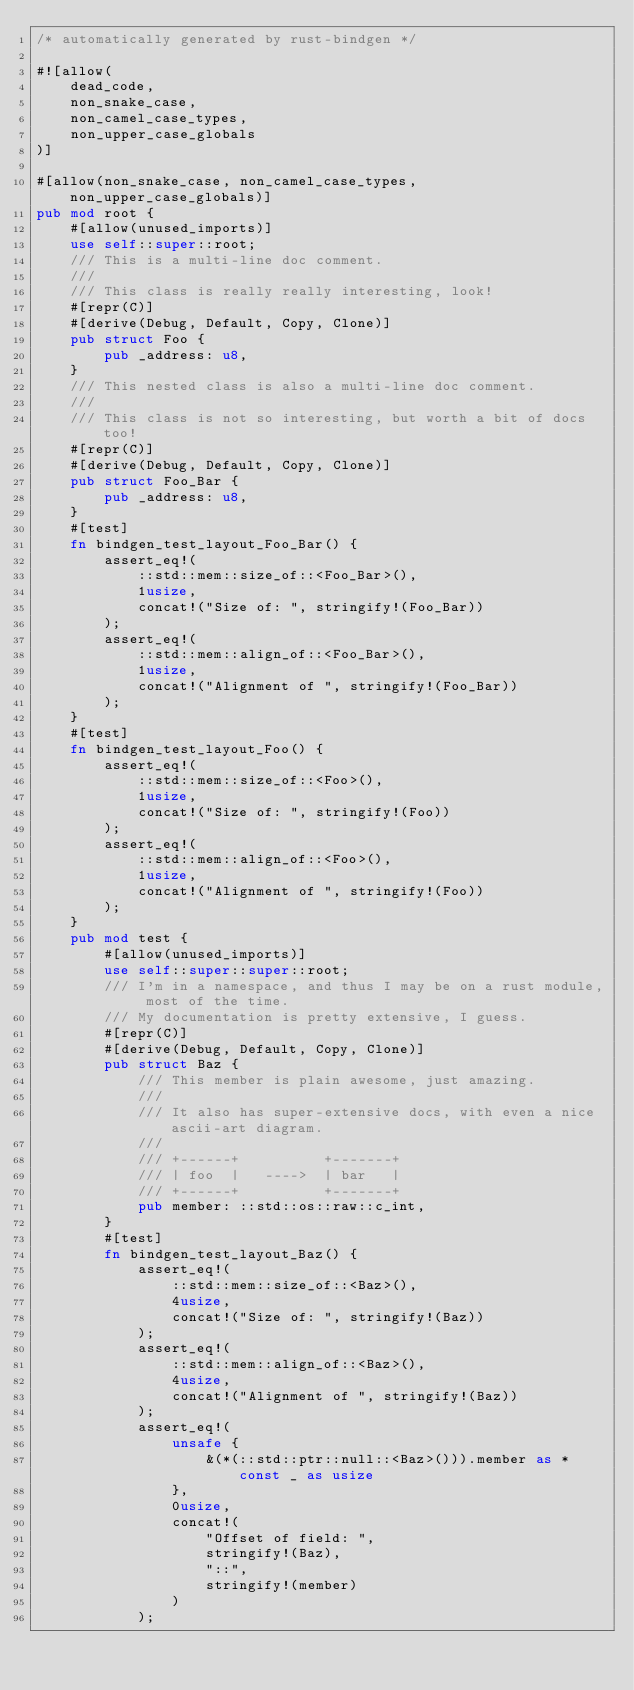Convert code to text. <code><loc_0><loc_0><loc_500><loc_500><_Rust_>/* automatically generated by rust-bindgen */

#![allow(
    dead_code,
    non_snake_case,
    non_camel_case_types,
    non_upper_case_globals
)]

#[allow(non_snake_case, non_camel_case_types, non_upper_case_globals)]
pub mod root {
    #[allow(unused_imports)]
    use self::super::root;
    /// This is a multi-line doc comment.
    ///
    /// This class is really really interesting, look!
    #[repr(C)]
    #[derive(Debug, Default, Copy, Clone)]
    pub struct Foo {
        pub _address: u8,
    }
    /// This nested class is also a multi-line doc comment.
    ///
    /// This class is not so interesting, but worth a bit of docs too!
    #[repr(C)]
    #[derive(Debug, Default, Copy, Clone)]
    pub struct Foo_Bar {
        pub _address: u8,
    }
    #[test]
    fn bindgen_test_layout_Foo_Bar() {
        assert_eq!(
            ::std::mem::size_of::<Foo_Bar>(),
            1usize,
            concat!("Size of: ", stringify!(Foo_Bar))
        );
        assert_eq!(
            ::std::mem::align_of::<Foo_Bar>(),
            1usize,
            concat!("Alignment of ", stringify!(Foo_Bar))
        );
    }
    #[test]
    fn bindgen_test_layout_Foo() {
        assert_eq!(
            ::std::mem::size_of::<Foo>(),
            1usize,
            concat!("Size of: ", stringify!(Foo))
        );
        assert_eq!(
            ::std::mem::align_of::<Foo>(),
            1usize,
            concat!("Alignment of ", stringify!(Foo))
        );
    }
    pub mod test {
        #[allow(unused_imports)]
        use self::super::super::root;
        /// I'm in a namespace, and thus I may be on a rust module, most of the time.
        /// My documentation is pretty extensive, I guess.
        #[repr(C)]
        #[derive(Debug, Default, Copy, Clone)]
        pub struct Baz {
            /// This member is plain awesome, just amazing.
            ///
            /// It also has super-extensive docs, with even a nice ascii-art diagram.
            ///
            /// +------+          +-------+
            /// | foo  |   ---->  | bar   |
            /// +------+          +-------+
            pub member: ::std::os::raw::c_int,
        }
        #[test]
        fn bindgen_test_layout_Baz() {
            assert_eq!(
                ::std::mem::size_of::<Baz>(),
                4usize,
                concat!("Size of: ", stringify!(Baz))
            );
            assert_eq!(
                ::std::mem::align_of::<Baz>(),
                4usize,
                concat!("Alignment of ", stringify!(Baz))
            );
            assert_eq!(
                unsafe {
                    &(*(::std::ptr::null::<Baz>())).member as *const _ as usize
                },
                0usize,
                concat!(
                    "Offset of field: ",
                    stringify!(Baz),
                    "::",
                    stringify!(member)
                )
            );</code> 